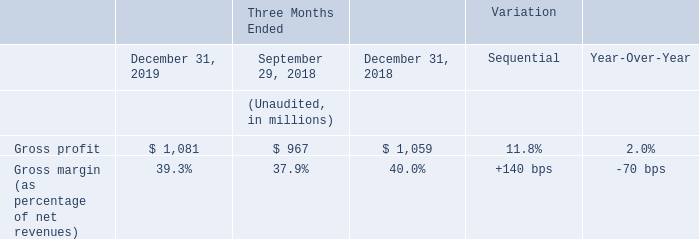Fourth quarter gross profit was $1,081 million and gross margin was 39.3%. On a sequential basis, gross margin increased 140 basis points, mainly driven by improved product mix and better manufacturing efficiencies.
Gross margin decreased 70 basis points year-over-year, mainly impacted by price pressure and unsaturation charges, partially offset by improved manufacturing efficiencies, better product mix and favorable currency effects, net of hedging.
What led to the increase in the gross margin on a sequential basis? Mainly driven by improved product mix and better manufacturing efficiencies. How much did the gross margin increase on a sequential basis 140 basis points. What led to the decrease in the gross margin year-over-year Mainly impacted by price pressure and unsaturation charges, partially offset by improved manufacturing efficiencies, better product mix and favorable currency effects, net of hedging. What is the average Gross profit for the period December 31, 2019 and 2018?
Answer scale should be: million. (1,081+1,059) / 2
Answer: 1070. What is the average Gross margin (as percentage of net revenues) for the period December 31, 2019 and 2018?
Answer scale should be: percent. (39.3+40.0) / 2
Answer: 39.65. What is the increase/ (decrease) in Gross profit from the period December 31, 2018 to 2019?
Answer scale should be: million. 1,081-1,059
Answer: 22. 